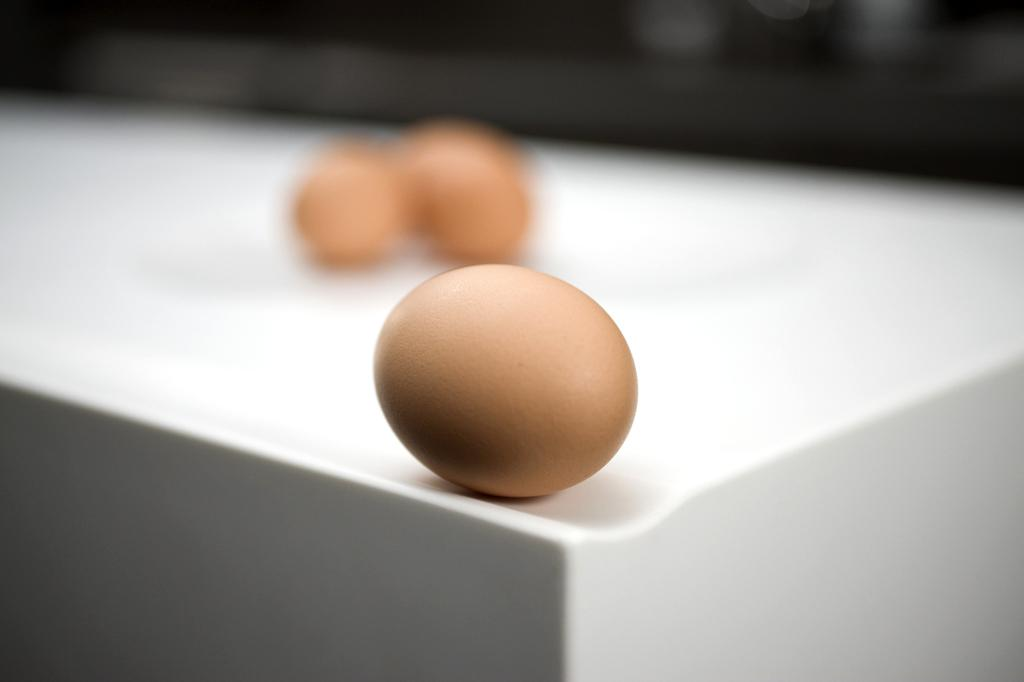What is located in the middle of the image? There is a table in the middle of the image. What items are on the table? There are eggs on the table. Can you describe the background of the image? The background of the image is blurred. What songs is the stranger singing in the image? There is no stranger present in the image, and therefore no singing can be observed. 